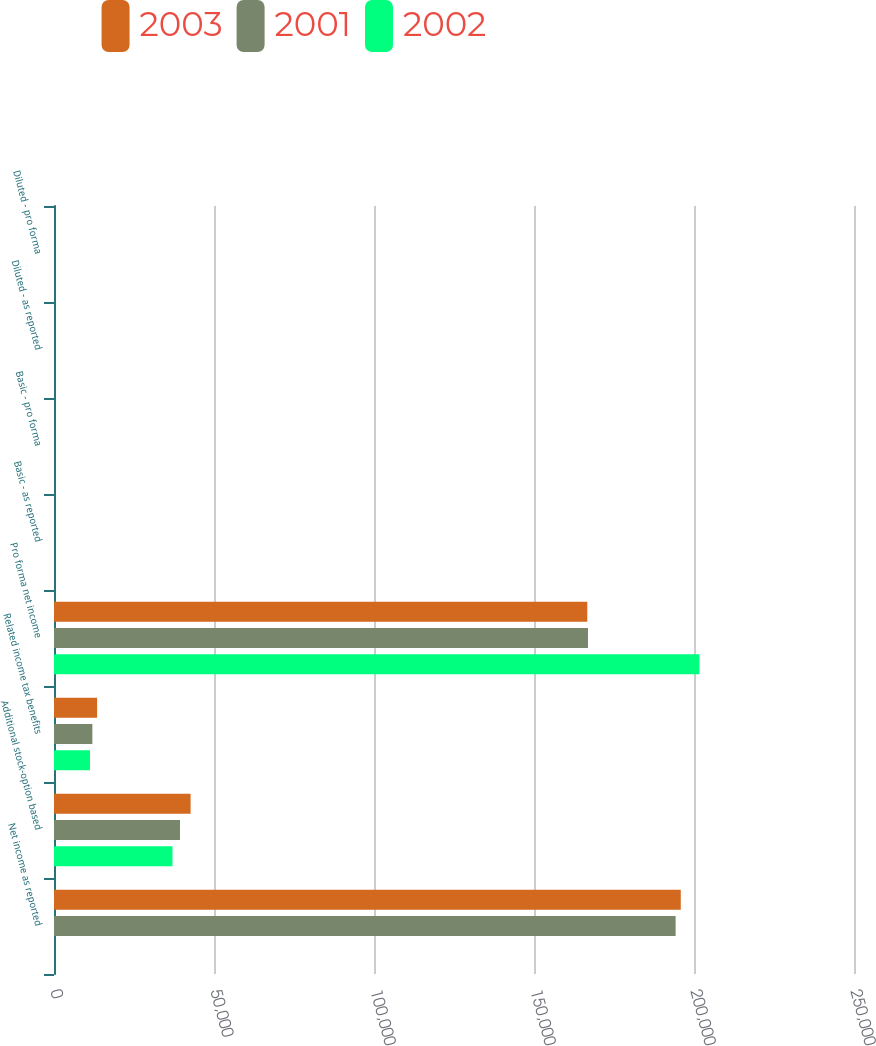Convert chart. <chart><loc_0><loc_0><loc_500><loc_500><stacked_bar_chart><ecel><fcel>Net income as reported<fcel>Additional stock-option based<fcel>Related income tax benefits<fcel>Pro forma net income<fcel>Basic - as reported<fcel>Basic - pro forma<fcel>Diluted - as reported<fcel>Diluted - pro forma<nl><fcel>2003<fcel>195868<fcel>42688<fcel>13471<fcel>166651<fcel>1.59<fcel>1.35<fcel>1.52<fcel>1.3<nl><fcel>2001<fcel>194254<fcel>39369<fcel>11985<fcel>166870<fcel>1.58<fcel>1.36<fcel>1.52<fcel>1.31<nl><fcel>2002<fcel>1.84<fcel>37028<fcel>11248<fcel>201707<fcel>1.84<fcel>1.63<fcel>1.77<fcel>1.59<nl></chart> 